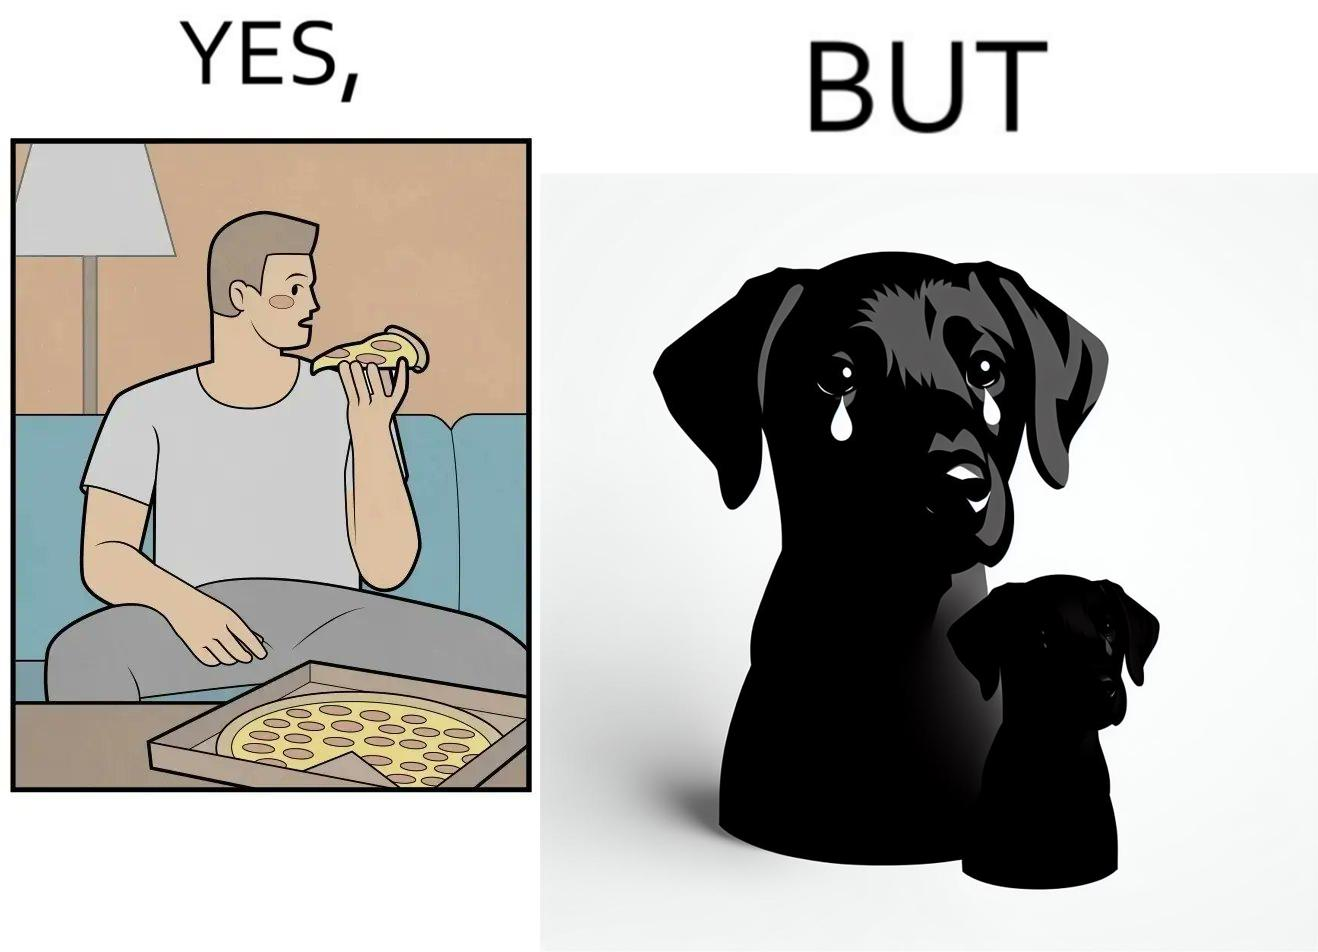Describe the satirical element in this image. The images are funny since they show how pet owners cannot enjoy any tasty food like pizza without sharing with their pets. The look from the pets makes the owner too guilty if he does not share his food 